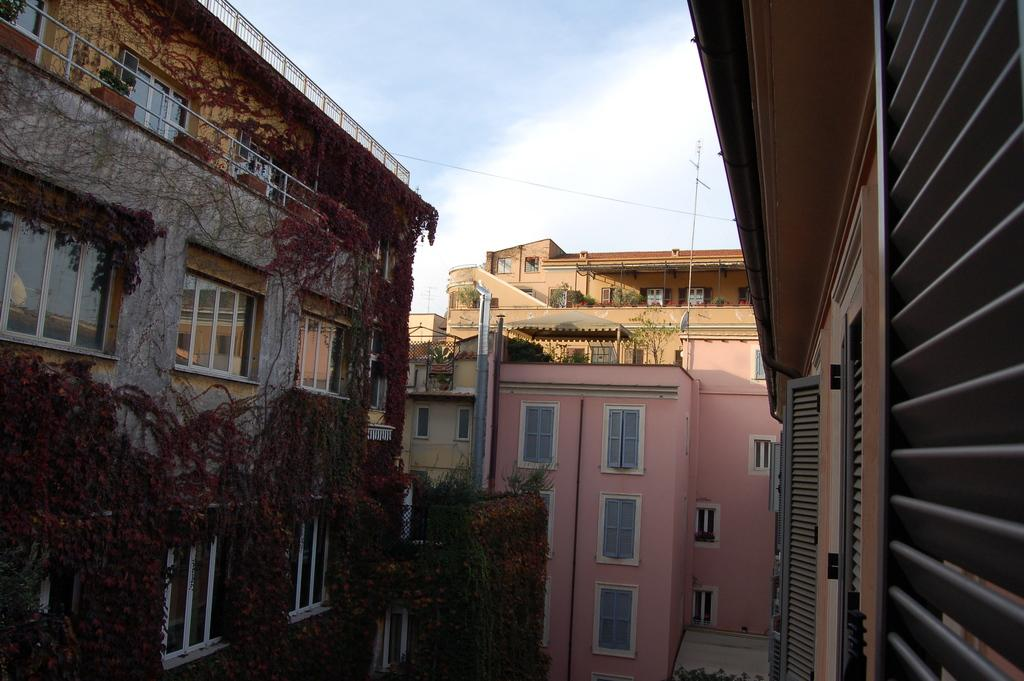What type of structures can be seen in the image? There are buildings in the image. What is covering the buildings? Moss is present on the buildings. What else can be seen in the image besides the buildings? There are poles in the image. What is visible in the background of the image? The sky is visible in the background of the image. Where is the market located in the image? There is no market present in the image. What type of beast can be seen roaming around the buildings in the image? There are no beasts present in the image; only buildings, moss, poles, and the sky are visible. 